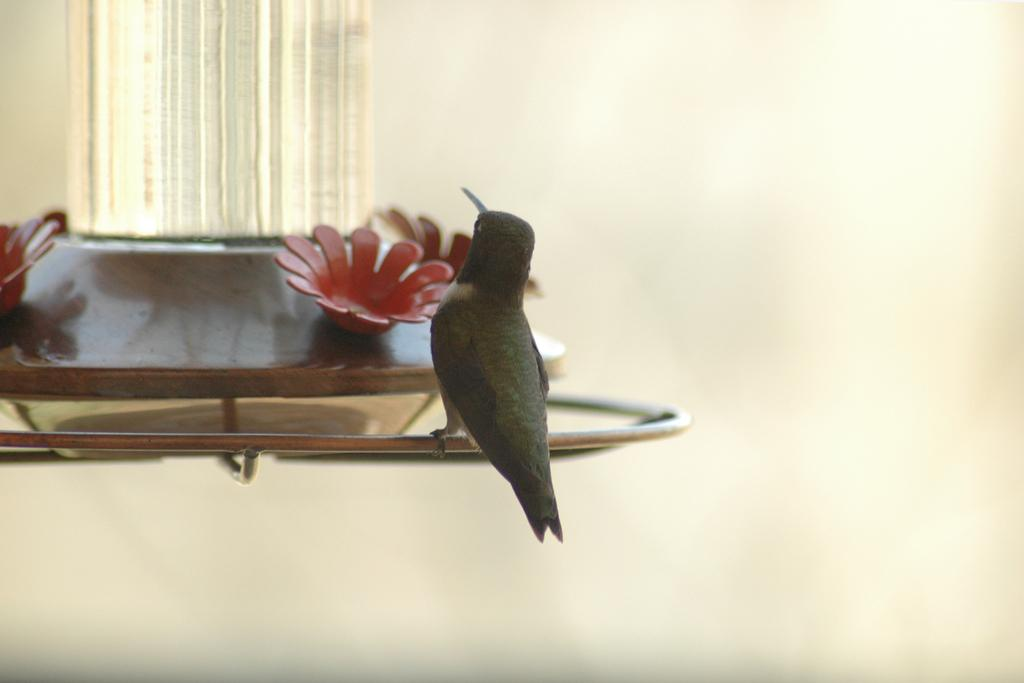What type of animal can be seen in the image? There is a bird in the image. What color is the bird? The bird is black in color. Is the bird driving a car in the image? No, there is no car or driving activity depicted in the image. The bird is simply perched or flying. 